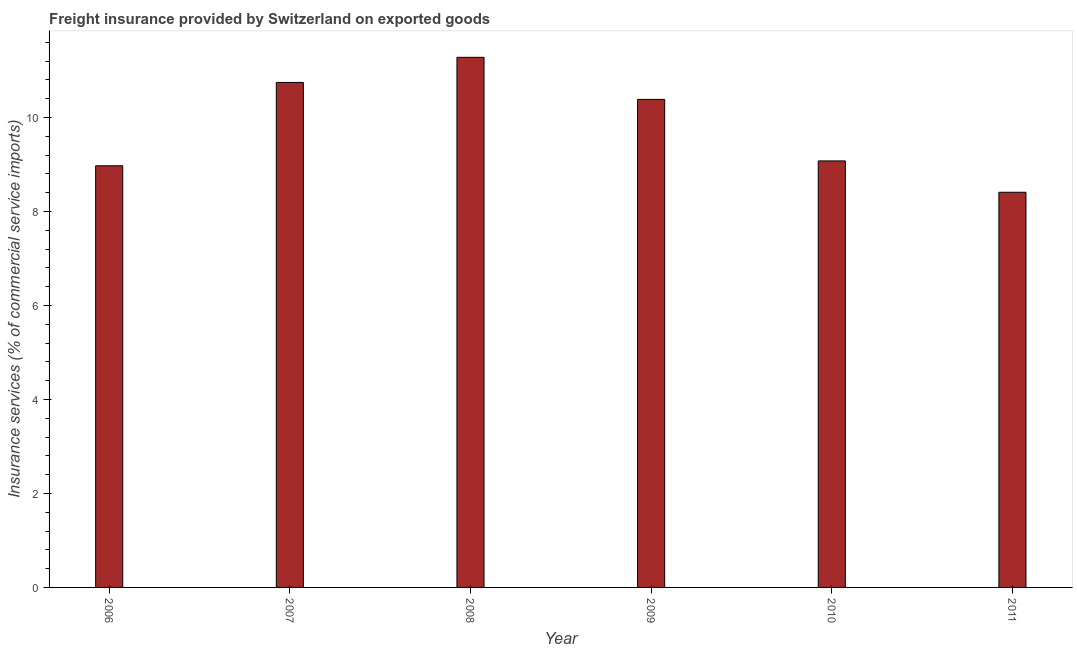What is the title of the graph?
Keep it short and to the point. Freight insurance provided by Switzerland on exported goods . What is the label or title of the X-axis?
Offer a very short reply. Year. What is the label or title of the Y-axis?
Offer a terse response. Insurance services (% of commercial service imports). What is the freight insurance in 2007?
Offer a terse response. 10.74. Across all years, what is the maximum freight insurance?
Provide a short and direct response. 11.28. Across all years, what is the minimum freight insurance?
Your answer should be very brief. 8.41. In which year was the freight insurance maximum?
Ensure brevity in your answer.  2008. What is the sum of the freight insurance?
Your answer should be compact. 58.86. What is the difference between the freight insurance in 2007 and 2011?
Provide a succinct answer. 2.34. What is the average freight insurance per year?
Your answer should be very brief. 9.81. What is the median freight insurance?
Keep it short and to the point. 9.73. What is the ratio of the freight insurance in 2006 to that in 2011?
Provide a short and direct response. 1.07. What is the difference between the highest and the second highest freight insurance?
Your response must be concise. 0.53. What is the difference between the highest and the lowest freight insurance?
Your answer should be very brief. 2.87. In how many years, is the freight insurance greater than the average freight insurance taken over all years?
Your answer should be very brief. 3. Are all the bars in the graph horizontal?
Offer a terse response. No. Are the values on the major ticks of Y-axis written in scientific E-notation?
Your answer should be very brief. No. What is the Insurance services (% of commercial service imports) of 2006?
Provide a short and direct response. 8.97. What is the Insurance services (% of commercial service imports) of 2007?
Your response must be concise. 10.74. What is the Insurance services (% of commercial service imports) in 2008?
Your response must be concise. 11.28. What is the Insurance services (% of commercial service imports) of 2009?
Provide a short and direct response. 10.38. What is the Insurance services (% of commercial service imports) in 2010?
Make the answer very short. 9.07. What is the Insurance services (% of commercial service imports) of 2011?
Give a very brief answer. 8.41. What is the difference between the Insurance services (% of commercial service imports) in 2006 and 2007?
Provide a short and direct response. -1.77. What is the difference between the Insurance services (% of commercial service imports) in 2006 and 2008?
Make the answer very short. -2.31. What is the difference between the Insurance services (% of commercial service imports) in 2006 and 2009?
Offer a very short reply. -1.41. What is the difference between the Insurance services (% of commercial service imports) in 2006 and 2010?
Offer a very short reply. -0.1. What is the difference between the Insurance services (% of commercial service imports) in 2006 and 2011?
Your answer should be compact. 0.56. What is the difference between the Insurance services (% of commercial service imports) in 2007 and 2008?
Provide a succinct answer. -0.53. What is the difference between the Insurance services (% of commercial service imports) in 2007 and 2009?
Your answer should be very brief. 0.36. What is the difference between the Insurance services (% of commercial service imports) in 2007 and 2010?
Your answer should be very brief. 1.67. What is the difference between the Insurance services (% of commercial service imports) in 2007 and 2011?
Keep it short and to the point. 2.34. What is the difference between the Insurance services (% of commercial service imports) in 2008 and 2009?
Provide a short and direct response. 0.89. What is the difference between the Insurance services (% of commercial service imports) in 2008 and 2010?
Your answer should be compact. 2.2. What is the difference between the Insurance services (% of commercial service imports) in 2008 and 2011?
Ensure brevity in your answer.  2.87. What is the difference between the Insurance services (% of commercial service imports) in 2009 and 2010?
Ensure brevity in your answer.  1.31. What is the difference between the Insurance services (% of commercial service imports) in 2009 and 2011?
Your answer should be compact. 1.98. What is the difference between the Insurance services (% of commercial service imports) in 2010 and 2011?
Your answer should be very brief. 0.67. What is the ratio of the Insurance services (% of commercial service imports) in 2006 to that in 2007?
Offer a very short reply. 0.83. What is the ratio of the Insurance services (% of commercial service imports) in 2006 to that in 2008?
Your answer should be very brief. 0.8. What is the ratio of the Insurance services (% of commercial service imports) in 2006 to that in 2009?
Provide a succinct answer. 0.86. What is the ratio of the Insurance services (% of commercial service imports) in 2006 to that in 2010?
Keep it short and to the point. 0.99. What is the ratio of the Insurance services (% of commercial service imports) in 2006 to that in 2011?
Keep it short and to the point. 1.07. What is the ratio of the Insurance services (% of commercial service imports) in 2007 to that in 2008?
Your answer should be compact. 0.95. What is the ratio of the Insurance services (% of commercial service imports) in 2007 to that in 2009?
Keep it short and to the point. 1.03. What is the ratio of the Insurance services (% of commercial service imports) in 2007 to that in 2010?
Make the answer very short. 1.18. What is the ratio of the Insurance services (% of commercial service imports) in 2007 to that in 2011?
Ensure brevity in your answer.  1.28. What is the ratio of the Insurance services (% of commercial service imports) in 2008 to that in 2009?
Your answer should be compact. 1.09. What is the ratio of the Insurance services (% of commercial service imports) in 2008 to that in 2010?
Offer a terse response. 1.24. What is the ratio of the Insurance services (% of commercial service imports) in 2008 to that in 2011?
Provide a succinct answer. 1.34. What is the ratio of the Insurance services (% of commercial service imports) in 2009 to that in 2010?
Your answer should be compact. 1.14. What is the ratio of the Insurance services (% of commercial service imports) in 2009 to that in 2011?
Your response must be concise. 1.24. What is the ratio of the Insurance services (% of commercial service imports) in 2010 to that in 2011?
Keep it short and to the point. 1.08. 